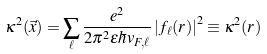Convert formula to latex. <formula><loc_0><loc_0><loc_500><loc_500>\kappa ^ { 2 } ( \vec { x } ) = \sum _ { \ell } \frac { e ^ { 2 } } { 2 \pi ^ { 2 } \epsilon \hbar { v } _ { F , \ell } } \left | f _ { \ell } ( r ) \right | ^ { 2 } \equiv \kappa ^ { 2 } ( r )</formula> 